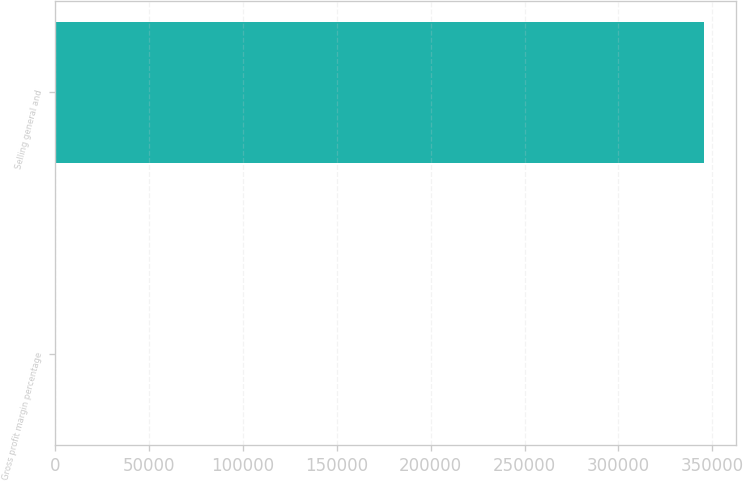<chart> <loc_0><loc_0><loc_500><loc_500><bar_chart><fcel>Gross profit margin percentage<fcel>Selling general and<nl><fcel>27.8<fcel>345525<nl></chart> 